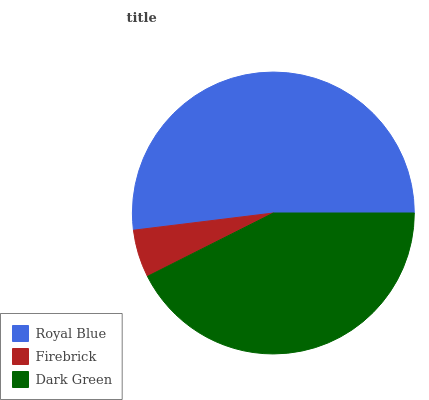Is Firebrick the minimum?
Answer yes or no. Yes. Is Royal Blue the maximum?
Answer yes or no. Yes. Is Dark Green the minimum?
Answer yes or no. No. Is Dark Green the maximum?
Answer yes or no. No. Is Dark Green greater than Firebrick?
Answer yes or no. Yes. Is Firebrick less than Dark Green?
Answer yes or no. Yes. Is Firebrick greater than Dark Green?
Answer yes or no. No. Is Dark Green less than Firebrick?
Answer yes or no. No. Is Dark Green the high median?
Answer yes or no. Yes. Is Dark Green the low median?
Answer yes or no. Yes. Is Royal Blue the high median?
Answer yes or no. No. Is Royal Blue the low median?
Answer yes or no. No. 